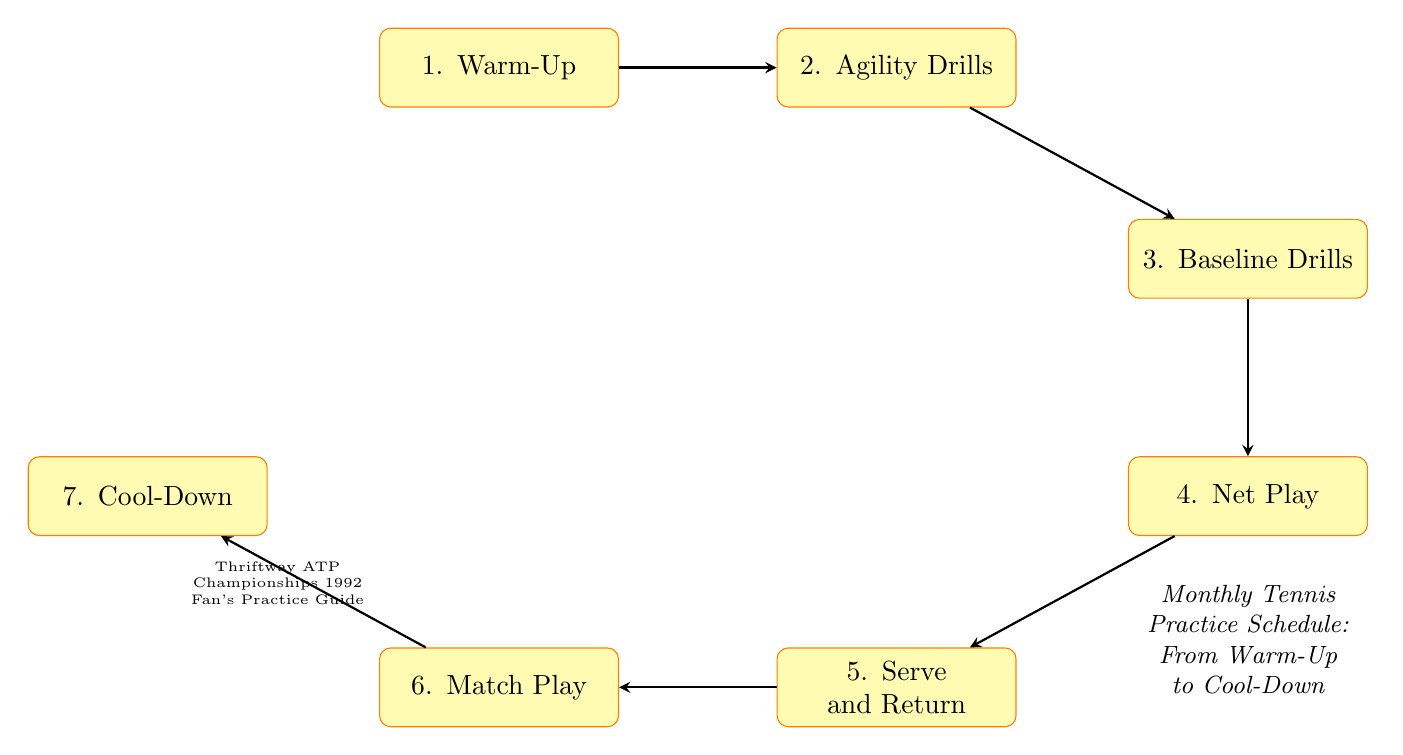What is the first step in the practice schedule? The first step is identified as "Warm-Up" at the top of the flow chart. It is positioned as the starting point before moving to the following activities.
Answer: Warm-Up How many practice steps are outlined in the diagram? Counting each distinct node in the diagram, there are a total of seven practice steps represented, from Warm-Up to Cool-Down.
Answer: 7 What is the last activity before Cool-Down? The node directly next to Cool-Down in the flow of the diagram is "Match Play," which comes right before the final Cool-Down step.
Answer: Match Play Which practice step focuses on footwork and reaction time? Referring to the flow chart, the node labeled "Agility Drills" specifically addresses footwork and reaction time, as stated in its description.
Answer: Agility Drills What sequence links Baseline Drills to Cool-Down? The flow from Baseline Drills to Cool-Down involves several steps: it connects to Net Play, then to Serve and Return, followed by Match Play, before reaching Cool-Down. This path indicates the operational flow.
Answer: Baseline Drills to Net Play to Serve and Return to Match Play to Cool-Down What type of drills improve serve techniques and return strategies? The node named "Serve and Return" in the diagram specifically illustrates the focus on serve techniques and return strategies, as expressed in its description.
Answer: Serve and Return Which step directly follows Net Play? The direction indicated in the flow chart shows that the step that immediately follows Net Play is "Serve and Return," which is positioned just below it in the sequence.
Answer: Serve and Return 